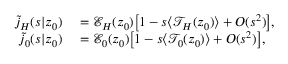<formula> <loc_0><loc_0><loc_500><loc_500>\begin{array} { r l } { \tilde { j } _ { H } ( s | z _ { 0 } ) } & = \mathcal { E } _ { H } ( z _ { 0 } ) \left [ 1 - s \langle \mathcal { T } _ { H } ( z _ { 0 } ) \rangle + O ( s ^ { 2 } ) \right ] , } \\ { \tilde { j } _ { 0 } ( s | z _ { 0 } ) } & = \mathcal { E } _ { 0 } ( z _ { 0 } ) \left [ 1 - s \langle \mathcal { T } _ { 0 } ( z _ { 0 } ) \rangle + O ( s ^ { 2 } ) \right ] , } \end{array}</formula> 